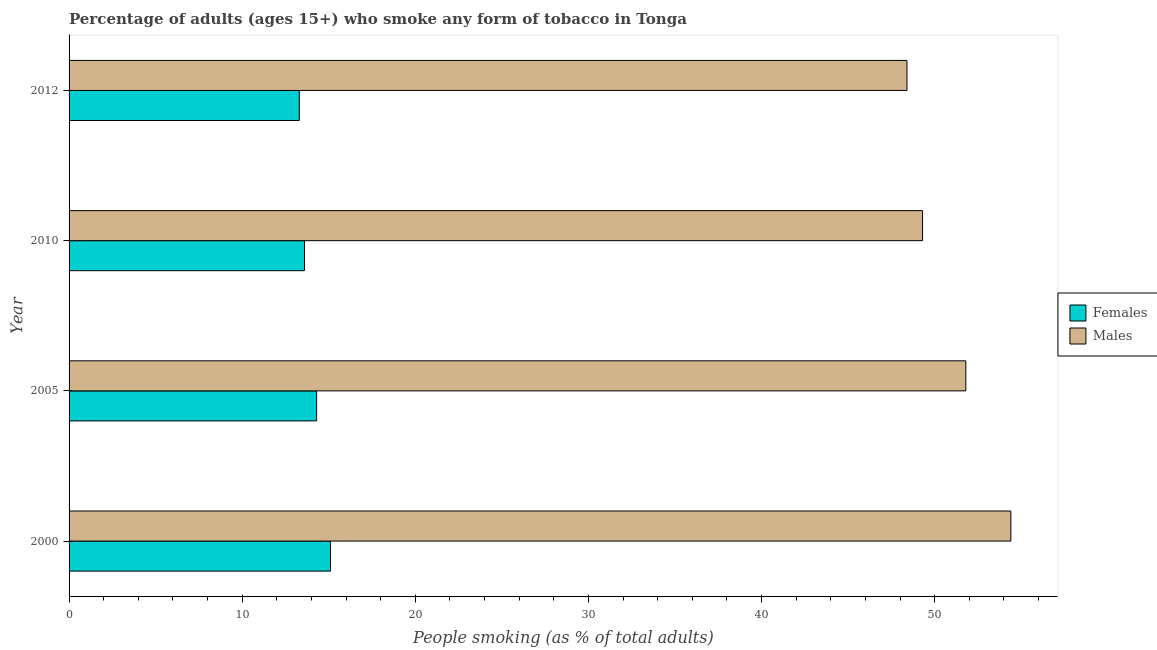How many different coloured bars are there?
Your response must be concise. 2. How many groups of bars are there?
Make the answer very short. 4. Are the number of bars per tick equal to the number of legend labels?
Provide a short and direct response. Yes. Are the number of bars on each tick of the Y-axis equal?
Offer a very short reply. Yes. How many bars are there on the 3rd tick from the top?
Keep it short and to the point. 2. What is the label of the 4th group of bars from the top?
Keep it short and to the point. 2000. Across all years, what is the maximum percentage of males who smoke?
Your answer should be very brief. 54.4. Across all years, what is the minimum percentage of males who smoke?
Offer a terse response. 48.4. In which year was the percentage of females who smoke maximum?
Your answer should be very brief. 2000. In which year was the percentage of females who smoke minimum?
Give a very brief answer. 2012. What is the total percentage of females who smoke in the graph?
Your answer should be compact. 56.3. What is the difference between the percentage of males who smoke in 2000 and that in 2005?
Offer a very short reply. 2.6. What is the difference between the percentage of females who smoke in 2010 and the percentage of males who smoke in 2012?
Offer a terse response. -34.8. What is the average percentage of males who smoke per year?
Offer a terse response. 50.98. In the year 2010, what is the difference between the percentage of males who smoke and percentage of females who smoke?
Your answer should be very brief. 35.7. What is the ratio of the percentage of males who smoke in 2000 to that in 2012?
Ensure brevity in your answer.  1.12. Is the difference between the percentage of males who smoke in 2005 and 2010 greater than the difference between the percentage of females who smoke in 2005 and 2010?
Offer a terse response. Yes. What is the difference between the highest and the lowest percentage of males who smoke?
Ensure brevity in your answer.  6. Is the sum of the percentage of males who smoke in 2000 and 2005 greater than the maximum percentage of females who smoke across all years?
Give a very brief answer. Yes. What does the 2nd bar from the top in 2000 represents?
Give a very brief answer. Females. What does the 1st bar from the bottom in 2010 represents?
Your response must be concise. Females. How many bars are there?
Your response must be concise. 8. Are all the bars in the graph horizontal?
Your answer should be very brief. Yes. What is the difference between two consecutive major ticks on the X-axis?
Provide a short and direct response. 10. Does the graph contain any zero values?
Ensure brevity in your answer.  No. How many legend labels are there?
Your answer should be compact. 2. How are the legend labels stacked?
Your answer should be very brief. Vertical. What is the title of the graph?
Make the answer very short. Percentage of adults (ages 15+) who smoke any form of tobacco in Tonga. What is the label or title of the X-axis?
Make the answer very short. People smoking (as % of total adults). What is the People smoking (as % of total adults) in Males in 2000?
Give a very brief answer. 54.4. What is the People smoking (as % of total adults) in Males in 2005?
Your answer should be compact. 51.8. What is the People smoking (as % of total adults) in Males in 2010?
Your answer should be very brief. 49.3. What is the People smoking (as % of total adults) of Males in 2012?
Keep it short and to the point. 48.4. Across all years, what is the maximum People smoking (as % of total adults) in Males?
Provide a short and direct response. 54.4. Across all years, what is the minimum People smoking (as % of total adults) of Females?
Ensure brevity in your answer.  13.3. Across all years, what is the minimum People smoking (as % of total adults) of Males?
Give a very brief answer. 48.4. What is the total People smoking (as % of total adults) of Females in the graph?
Your answer should be compact. 56.3. What is the total People smoking (as % of total adults) in Males in the graph?
Make the answer very short. 203.9. What is the difference between the People smoking (as % of total adults) in Males in 2000 and that in 2010?
Make the answer very short. 5.1. What is the difference between the People smoking (as % of total adults) in Females in 2005 and that in 2010?
Ensure brevity in your answer.  0.7. What is the difference between the People smoking (as % of total adults) of Males in 2005 and that in 2010?
Your answer should be very brief. 2.5. What is the difference between the People smoking (as % of total adults) of Females in 2005 and that in 2012?
Your response must be concise. 1. What is the difference between the People smoking (as % of total adults) in Females in 2010 and that in 2012?
Offer a very short reply. 0.3. What is the difference between the People smoking (as % of total adults) of Females in 2000 and the People smoking (as % of total adults) of Males in 2005?
Offer a very short reply. -36.7. What is the difference between the People smoking (as % of total adults) in Females in 2000 and the People smoking (as % of total adults) in Males in 2010?
Make the answer very short. -34.2. What is the difference between the People smoking (as % of total adults) of Females in 2000 and the People smoking (as % of total adults) of Males in 2012?
Make the answer very short. -33.3. What is the difference between the People smoking (as % of total adults) in Females in 2005 and the People smoking (as % of total adults) in Males in 2010?
Offer a very short reply. -35. What is the difference between the People smoking (as % of total adults) of Females in 2005 and the People smoking (as % of total adults) of Males in 2012?
Keep it short and to the point. -34.1. What is the difference between the People smoking (as % of total adults) in Females in 2010 and the People smoking (as % of total adults) in Males in 2012?
Offer a very short reply. -34.8. What is the average People smoking (as % of total adults) of Females per year?
Give a very brief answer. 14.07. What is the average People smoking (as % of total adults) in Males per year?
Your answer should be compact. 50.98. In the year 2000, what is the difference between the People smoking (as % of total adults) of Females and People smoking (as % of total adults) of Males?
Offer a terse response. -39.3. In the year 2005, what is the difference between the People smoking (as % of total adults) in Females and People smoking (as % of total adults) in Males?
Provide a succinct answer. -37.5. In the year 2010, what is the difference between the People smoking (as % of total adults) of Females and People smoking (as % of total adults) of Males?
Your answer should be compact. -35.7. In the year 2012, what is the difference between the People smoking (as % of total adults) in Females and People smoking (as % of total adults) in Males?
Your answer should be compact. -35.1. What is the ratio of the People smoking (as % of total adults) of Females in 2000 to that in 2005?
Your answer should be very brief. 1.06. What is the ratio of the People smoking (as % of total adults) of Males in 2000 to that in 2005?
Provide a succinct answer. 1.05. What is the ratio of the People smoking (as % of total adults) of Females in 2000 to that in 2010?
Ensure brevity in your answer.  1.11. What is the ratio of the People smoking (as % of total adults) in Males in 2000 to that in 2010?
Your response must be concise. 1.1. What is the ratio of the People smoking (as % of total adults) in Females in 2000 to that in 2012?
Provide a short and direct response. 1.14. What is the ratio of the People smoking (as % of total adults) of Males in 2000 to that in 2012?
Your answer should be compact. 1.12. What is the ratio of the People smoking (as % of total adults) in Females in 2005 to that in 2010?
Make the answer very short. 1.05. What is the ratio of the People smoking (as % of total adults) of Males in 2005 to that in 2010?
Your answer should be very brief. 1.05. What is the ratio of the People smoking (as % of total adults) of Females in 2005 to that in 2012?
Offer a terse response. 1.08. What is the ratio of the People smoking (as % of total adults) of Males in 2005 to that in 2012?
Provide a short and direct response. 1.07. What is the ratio of the People smoking (as % of total adults) in Females in 2010 to that in 2012?
Provide a succinct answer. 1.02. What is the ratio of the People smoking (as % of total adults) in Males in 2010 to that in 2012?
Your response must be concise. 1.02. What is the difference between the highest and the lowest People smoking (as % of total adults) of Females?
Provide a succinct answer. 1.8. 